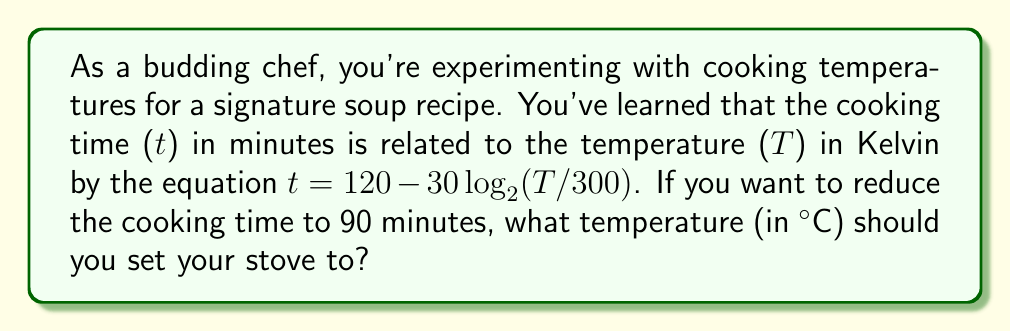Give your solution to this math problem. Let's approach this step-by-step:

1) We're given the equation: $t = 120 - 30\log_{2}(T/300)$

2) We want $t = 90$ minutes. Let's substitute this into the equation:
   
   $90 = 120 - 30\log_{2}(T/300)$

3) Subtract 120 from both sides:
   
   $-30 = -30\log_{2}(T/300)$

4) Divide both sides by -30:
   
   $1 = \log_{2}(T/300)$

5) Now, we can apply $2^x$ to both sides (since $2^{\log_{2}x} = x$):
   
   $2^1 = T/300$

6) Simplify:
   
   $2 = T/300$

7) Multiply both sides by 300:
   
   $600 = T$

8) So the temperature should be 600 Kelvin. But we need to convert this to Celsius.
   The formula is: $°C = K - 273.15$

9) Applying this:
   
   $°C = 600 - 273.15 = 326.85$

10) Rounding to the nearest degree: 327°C
Answer: 327°C 